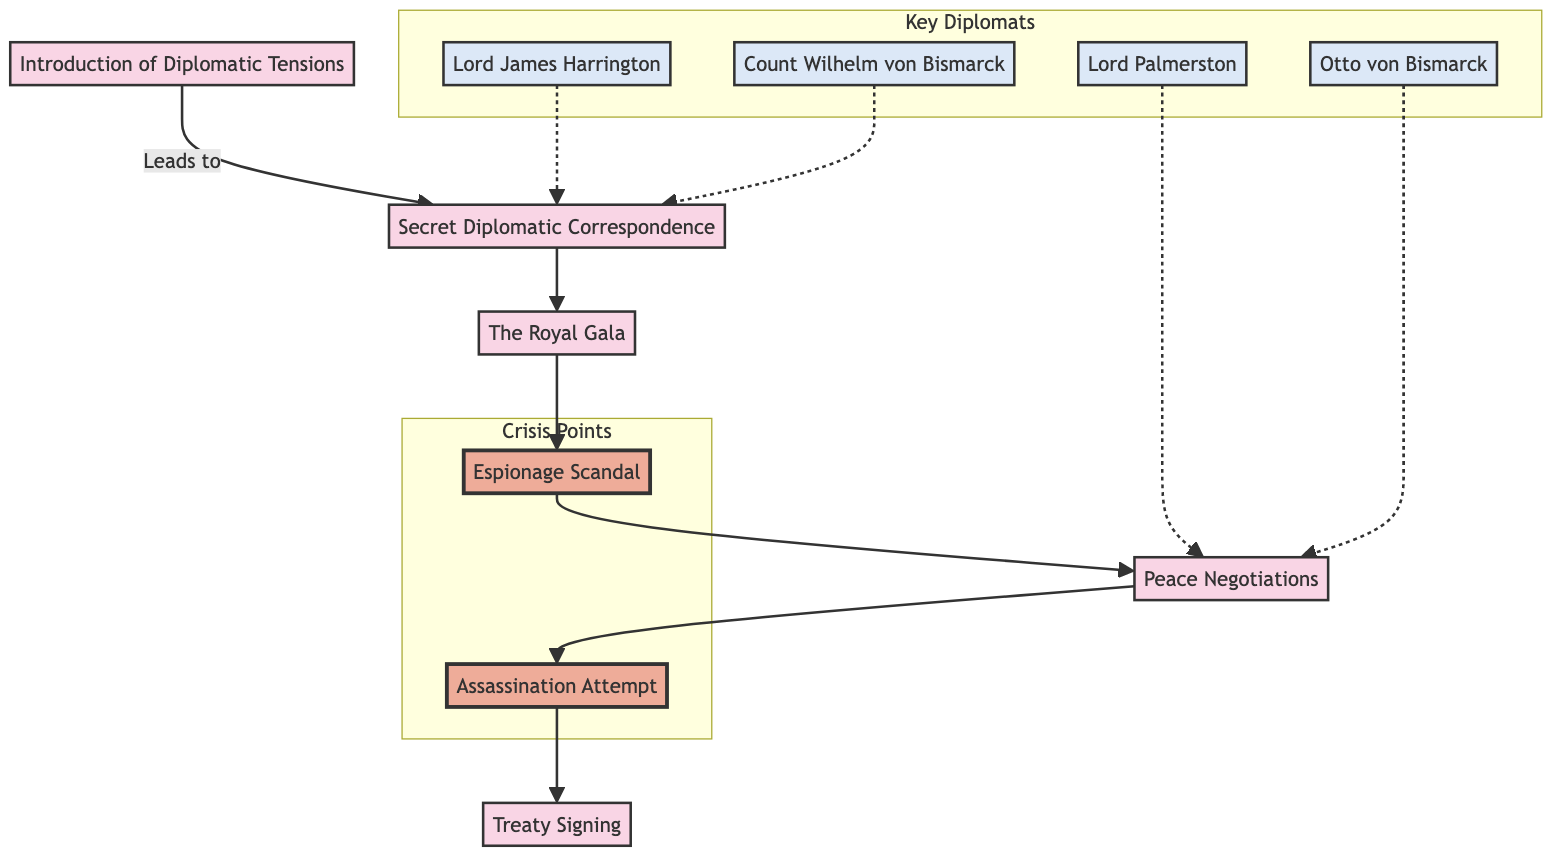What is the first event in the flowchart? The flowchart lists "Introduction of Diplomatic Tensions" as the first event, which is the starting point of the sequence.
Answer: Introduction of Diplomatic Tensions How many crisis points are shown in the diagram? There are two specific crisis points indicated in the diagram: "Espionage Scandal" and "Assassination Attempt."
Answer: 2 Which diplomat is linked to the "Peace Negotiations"? The flowchart connects both "Lord Palmerston" and "Otto von Bismarck" to the "Peace Negotiations," indicating their involvement in that stage.
Answer: Lord Palmerston, Otto von Bismarck What impact does the "Espionage Scandal" have on diplomatic talks? The "Espionage Scandal" leads to a "Temporary break in diplomatic talks and increased tensions," indicating its negative effect on diplomacy.
Answer: Temporary break in diplomatic talks and increased tensions What leads from "The Royal Gala" to the next event in the sequence? According to the flowchart, "The Royal Gala" leads to "Espionage Scandal," so it is a direct connection in the sequence.
Answer: Espionage Scandal Which two diplomats are involved in secret negotiations? "Lord James Harrington" and "Count Wilhelm von Bismarck" are shown to have a connection in the flowchart, implying their participation in secret negotiations.
Answer: Lord James Harrington, Count Wilhelm von Bismarck What event occurs immediately after "Assassination Attempt"? Following the "Assassination Attempt," the diagram indicates the next event is the "Treaty Signing," showing the sequence of events.
Answer: Treaty Signing Which event culminates the flow of diplomatic events in this diagram? The final event in the flowchart is the "Treaty Signing," which signifies the resolution of the depicted tensions.
Answer: Treaty Signing What is the primary role of Lord James Harrington in the flowchart? Lord James Harrington's role is described as the "Chief British Diplomat striving to maintain peace," highlighting his diplomatic efforts.
Answer: Chief British Diplomat striving to maintain peace 